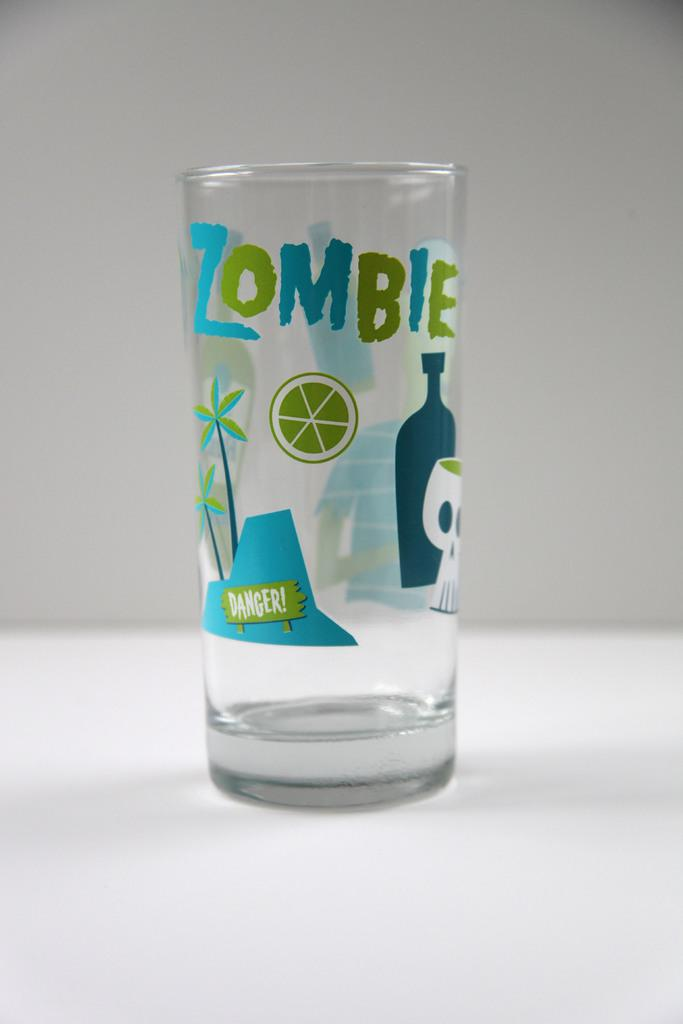What object is present in the image that is typically used for holding liquids? There is a glass in the image. Can you describe any specific features of the glass? The glass has a design and text on it. What is the color of the background in the image? The background of the image is white. How many trees can be seen growing inside the glass in the image? There are no trees visible inside the glass in the image. Are there any spiders or robins present in the image? There are no spiders or robins present in the image. 